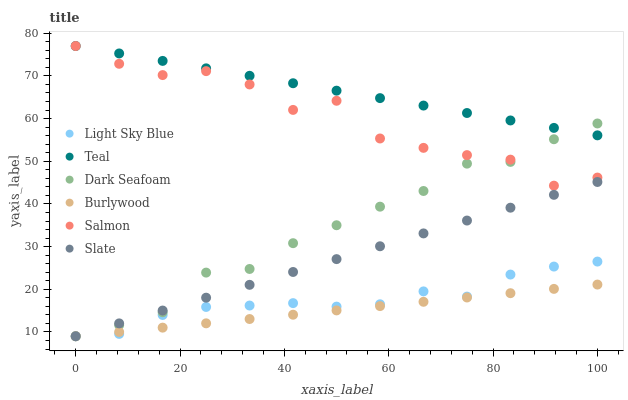Does Burlywood have the minimum area under the curve?
Answer yes or no. Yes. Does Teal have the maximum area under the curve?
Answer yes or no. Yes. Does Slate have the minimum area under the curve?
Answer yes or no. No. Does Slate have the maximum area under the curve?
Answer yes or no. No. Is Slate the smoothest?
Answer yes or no. Yes. Is Salmon the roughest?
Answer yes or no. Yes. Is Salmon the smoothest?
Answer yes or no. No. Is Slate the roughest?
Answer yes or no. No. Does Burlywood have the lowest value?
Answer yes or no. Yes. Does Salmon have the lowest value?
Answer yes or no. No. Does Teal have the highest value?
Answer yes or no. Yes. Does Slate have the highest value?
Answer yes or no. No. Is Light Sky Blue less than Teal?
Answer yes or no. Yes. Is Teal greater than Slate?
Answer yes or no. Yes. Does Teal intersect Dark Seafoam?
Answer yes or no. Yes. Is Teal less than Dark Seafoam?
Answer yes or no. No. Is Teal greater than Dark Seafoam?
Answer yes or no. No. Does Light Sky Blue intersect Teal?
Answer yes or no. No. 